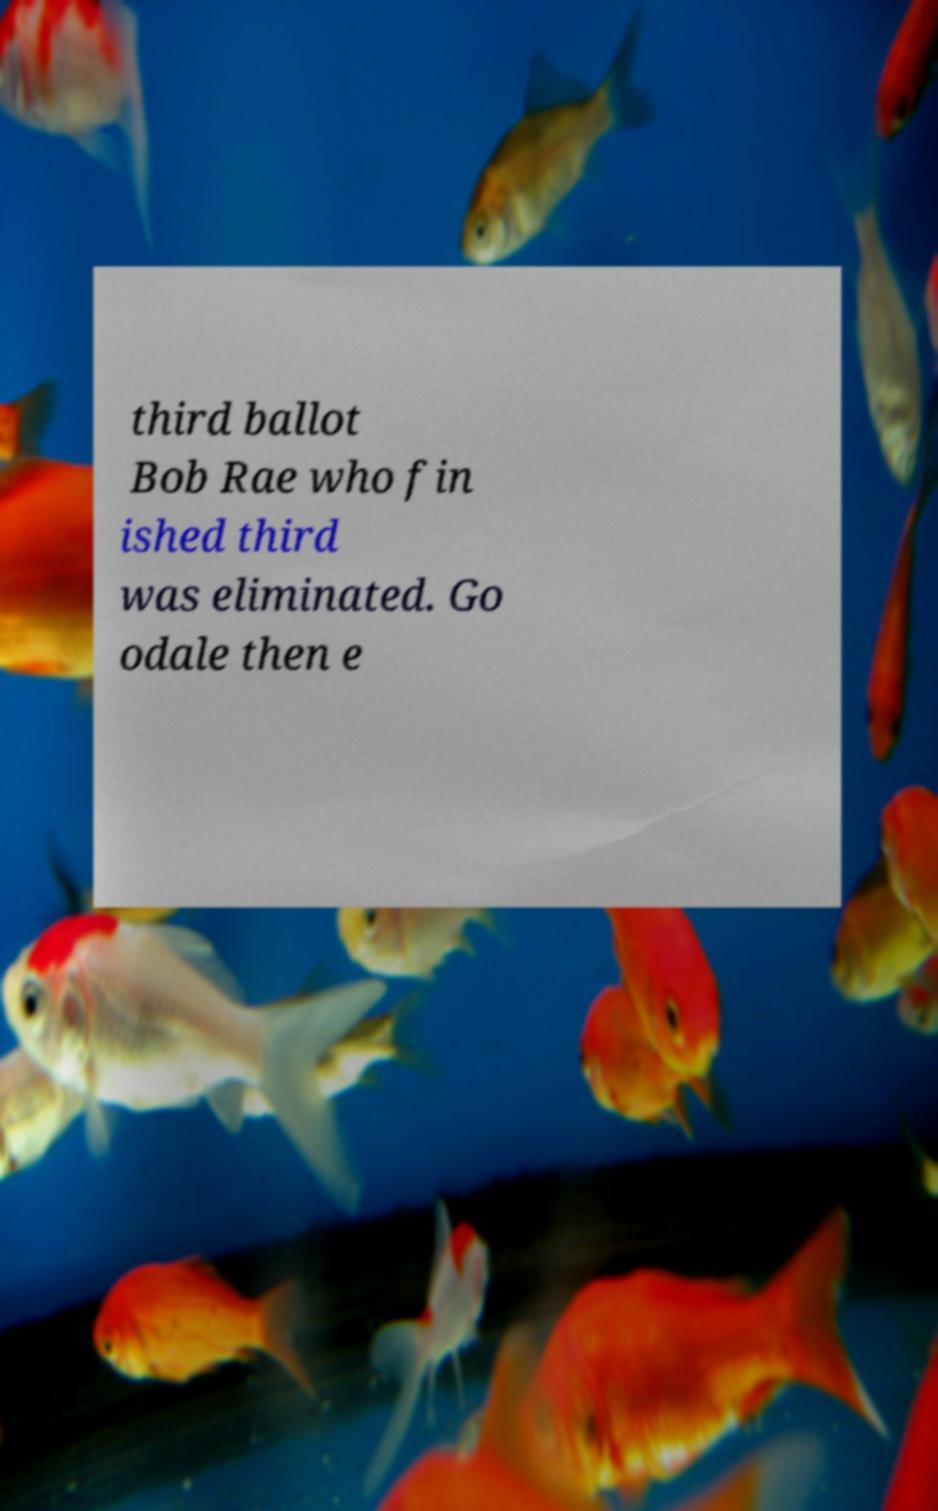Could you extract and type out the text from this image? third ballot Bob Rae who fin ished third was eliminated. Go odale then e 